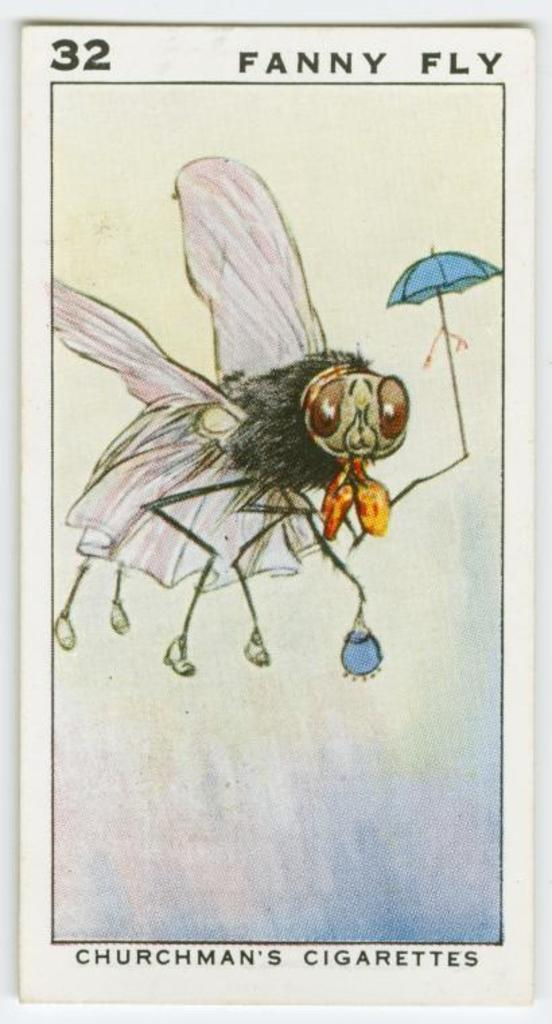What is the main object in the image? There is a card in the image. Where is the card placed? The card is placed on a white surface. What can be found on the card? There is text on the card, as well as paintings of a fly and an umbrella. How many spies are depicted in the painting of the fly on the card? There are no spies depicted in the painting of the fly on the card, as it is a painting of a fly and not a scene involving spies. 